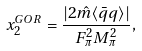Convert formula to latex. <formula><loc_0><loc_0><loc_500><loc_500>x _ { 2 } ^ { G O R } = \frac { | 2 \hat { m } \langle \bar { q } q \rangle | } { F _ { \pi } ^ { 2 } M _ { \pi } ^ { 2 } } ,</formula> 